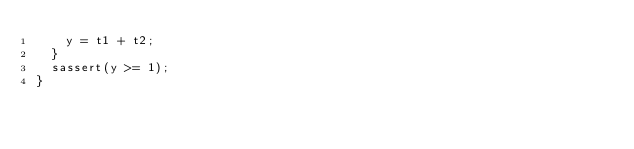Convert code to text. <code><loc_0><loc_0><loc_500><loc_500><_C_>    y = t1 + t2;
  }
  sassert(y >= 1);
}
</code> 